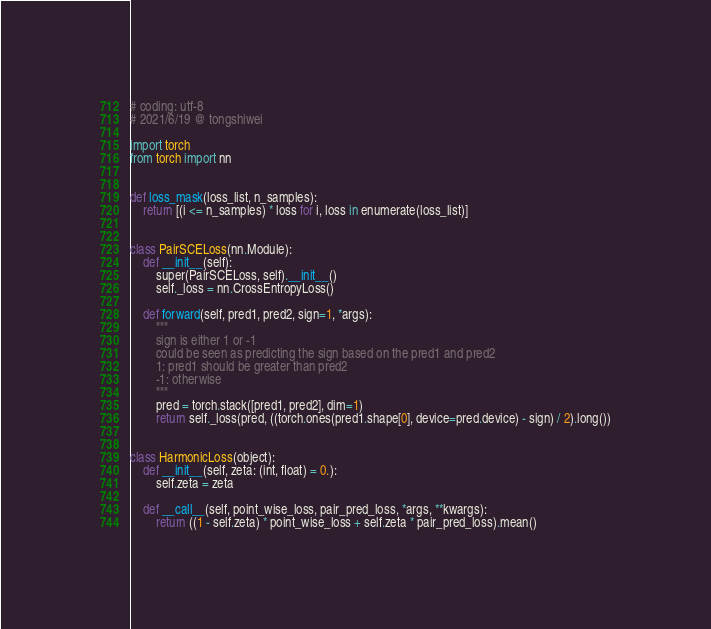Convert code to text. <code><loc_0><loc_0><loc_500><loc_500><_Python_># coding: utf-8
# 2021/6/19 @ tongshiwei

import torch
from torch import nn


def loss_mask(loss_list, n_samples):
    return [(i <= n_samples) * loss for i, loss in enumerate(loss_list)]


class PairSCELoss(nn.Module):
    def __init__(self):
        super(PairSCELoss, self).__init__()
        self._loss = nn.CrossEntropyLoss()

    def forward(self, pred1, pred2, sign=1, *args):
        """
        sign is either 1 or -1
        could be seen as predicting the sign based on the pred1 and pred2
        1: pred1 should be greater than pred2
        -1: otherwise
        """
        pred = torch.stack([pred1, pred2], dim=1)
        return self._loss(pred, ((torch.ones(pred1.shape[0], device=pred.device) - sign) / 2).long())


class HarmonicLoss(object):
    def __init__(self, zeta: (int, float) = 0.):
        self.zeta = zeta

    def __call__(self, point_wise_loss, pair_pred_loss, *args, **kwargs):
        return ((1 - self.zeta) * point_wise_loss + self.zeta * pair_pred_loss).mean()
</code> 